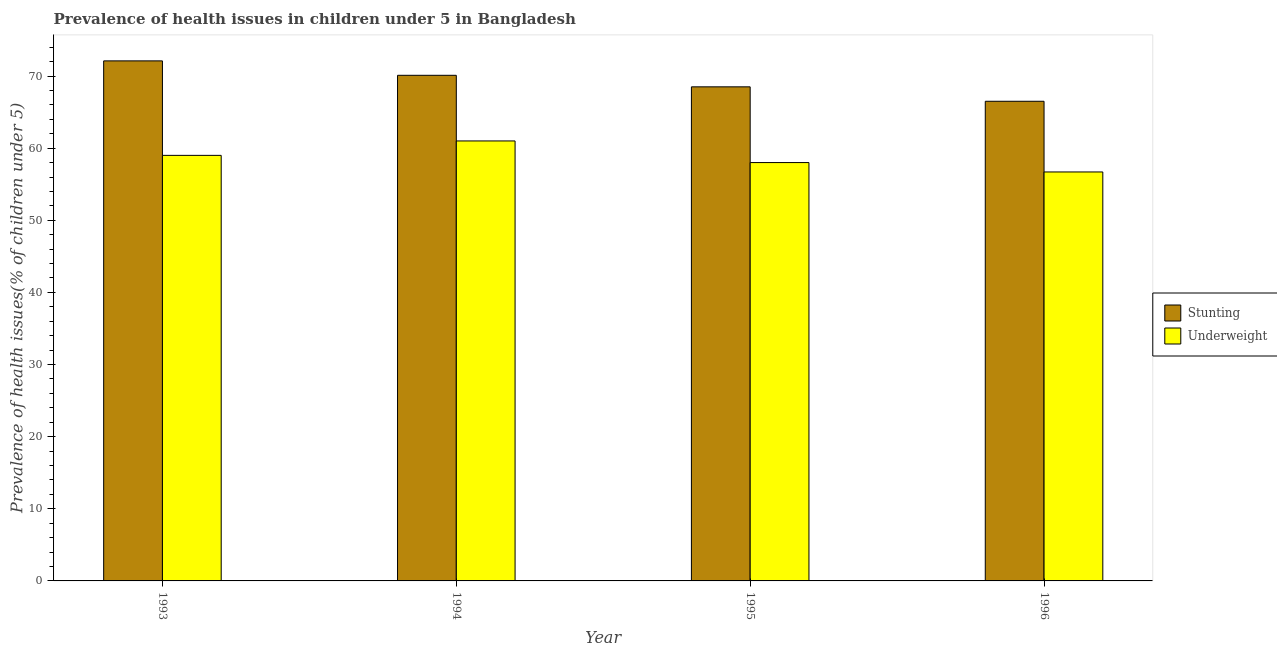How many different coloured bars are there?
Keep it short and to the point. 2. How many groups of bars are there?
Provide a short and direct response. 4. Are the number of bars per tick equal to the number of legend labels?
Give a very brief answer. Yes. Are the number of bars on each tick of the X-axis equal?
Offer a terse response. Yes. How many bars are there on the 2nd tick from the right?
Provide a short and direct response. 2. In how many cases, is the number of bars for a given year not equal to the number of legend labels?
Offer a terse response. 0. Across all years, what is the maximum percentage of underweight children?
Give a very brief answer. 61. Across all years, what is the minimum percentage of stunted children?
Keep it short and to the point. 66.5. In which year was the percentage of stunted children minimum?
Ensure brevity in your answer.  1996. What is the total percentage of underweight children in the graph?
Offer a terse response. 234.7. What is the difference between the percentage of stunted children in 1994 and that in 1996?
Offer a very short reply. 3.6. What is the average percentage of stunted children per year?
Your answer should be compact. 69.3. In how many years, is the percentage of stunted children greater than 10 %?
Your response must be concise. 4. What is the ratio of the percentage of stunted children in 1993 to that in 1995?
Keep it short and to the point. 1.05. Is the percentage of underweight children in 1993 less than that in 1994?
Your answer should be very brief. Yes. What is the difference between the highest and the second highest percentage of underweight children?
Offer a very short reply. 2. What is the difference between the highest and the lowest percentage of underweight children?
Make the answer very short. 4.3. In how many years, is the percentage of stunted children greater than the average percentage of stunted children taken over all years?
Your answer should be very brief. 2. What does the 2nd bar from the left in 1993 represents?
Provide a succinct answer. Underweight. What does the 1st bar from the right in 1995 represents?
Give a very brief answer. Underweight. How many years are there in the graph?
Make the answer very short. 4. Are the values on the major ticks of Y-axis written in scientific E-notation?
Give a very brief answer. No. Does the graph contain any zero values?
Offer a terse response. No. Where does the legend appear in the graph?
Your answer should be compact. Center right. How are the legend labels stacked?
Provide a short and direct response. Vertical. What is the title of the graph?
Give a very brief answer. Prevalence of health issues in children under 5 in Bangladesh. What is the label or title of the Y-axis?
Provide a succinct answer. Prevalence of health issues(% of children under 5). What is the Prevalence of health issues(% of children under 5) of Stunting in 1993?
Offer a terse response. 72.1. What is the Prevalence of health issues(% of children under 5) in Underweight in 1993?
Make the answer very short. 59. What is the Prevalence of health issues(% of children under 5) of Stunting in 1994?
Offer a very short reply. 70.1. What is the Prevalence of health issues(% of children under 5) in Underweight in 1994?
Provide a succinct answer. 61. What is the Prevalence of health issues(% of children under 5) in Stunting in 1995?
Your answer should be compact. 68.5. What is the Prevalence of health issues(% of children under 5) of Underweight in 1995?
Give a very brief answer. 58. What is the Prevalence of health issues(% of children under 5) in Stunting in 1996?
Provide a succinct answer. 66.5. What is the Prevalence of health issues(% of children under 5) of Underweight in 1996?
Keep it short and to the point. 56.7. Across all years, what is the maximum Prevalence of health issues(% of children under 5) of Stunting?
Make the answer very short. 72.1. Across all years, what is the maximum Prevalence of health issues(% of children under 5) of Underweight?
Offer a very short reply. 61. Across all years, what is the minimum Prevalence of health issues(% of children under 5) of Stunting?
Provide a short and direct response. 66.5. Across all years, what is the minimum Prevalence of health issues(% of children under 5) of Underweight?
Provide a succinct answer. 56.7. What is the total Prevalence of health issues(% of children under 5) in Stunting in the graph?
Provide a short and direct response. 277.2. What is the total Prevalence of health issues(% of children under 5) in Underweight in the graph?
Give a very brief answer. 234.7. What is the difference between the Prevalence of health issues(% of children under 5) in Stunting in 1993 and that in 1996?
Keep it short and to the point. 5.6. What is the difference between the Prevalence of health issues(% of children under 5) in Underweight in 1993 and that in 1996?
Your answer should be very brief. 2.3. What is the difference between the Prevalence of health issues(% of children under 5) of Stunting in 1995 and that in 1996?
Provide a short and direct response. 2. What is the difference between the Prevalence of health issues(% of children under 5) in Underweight in 1995 and that in 1996?
Your response must be concise. 1.3. What is the difference between the Prevalence of health issues(% of children under 5) of Stunting in 1993 and the Prevalence of health issues(% of children under 5) of Underweight in 1994?
Give a very brief answer. 11.1. What is the difference between the Prevalence of health issues(% of children under 5) of Stunting in 1993 and the Prevalence of health issues(% of children under 5) of Underweight in 1996?
Ensure brevity in your answer.  15.4. What is the difference between the Prevalence of health issues(% of children under 5) in Stunting in 1994 and the Prevalence of health issues(% of children under 5) in Underweight in 1995?
Make the answer very short. 12.1. What is the average Prevalence of health issues(% of children under 5) in Stunting per year?
Provide a succinct answer. 69.3. What is the average Prevalence of health issues(% of children under 5) of Underweight per year?
Offer a terse response. 58.67. In the year 1994, what is the difference between the Prevalence of health issues(% of children under 5) in Stunting and Prevalence of health issues(% of children under 5) in Underweight?
Offer a very short reply. 9.1. What is the ratio of the Prevalence of health issues(% of children under 5) of Stunting in 1993 to that in 1994?
Provide a succinct answer. 1.03. What is the ratio of the Prevalence of health issues(% of children under 5) of Underweight in 1993 to that in 1994?
Your response must be concise. 0.97. What is the ratio of the Prevalence of health issues(% of children under 5) of Stunting in 1993 to that in 1995?
Provide a succinct answer. 1.05. What is the ratio of the Prevalence of health issues(% of children under 5) of Underweight in 1993 to that in 1995?
Make the answer very short. 1.02. What is the ratio of the Prevalence of health issues(% of children under 5) in Stunting in 1993 to that in 1996?
Offer a very short reply. 1.08. What is the ratio of the Prevalence of health issues(% of children under 5) in Underweight in 1993 to that in 1996?
Make the answer very short. 1.04. What is the ratio of the Prevalence of health issues(% of children under 5) in Stunting in 1994 to that in 1995?
Your answer should be compact. 1.02. What is the ratio of the Prevalence of health issues(% of children under 5) in Underweight in 1994 to that in 1995?
Your answer should be very brief. 1.05. What is the ratio of the Prevalence of health issues(% of children under 5) of Stunting in 1994 to that in 1996?
Give a very brief answer. 1.05. What is the ratio of the Prevalence of health issues(% of children under 5) of Underweight in 1994 to that in 1996?
Make the answer very short. 1.08. What is the ratio of the Prevalence of health issues(% of children under 5) of Stunting in 1995 to that in 1996?
Your answer should be very brief. 1.03. What is the ratio of the Prevalence of health issues(% of children under 5) in Underweight in 1995 to that in 1996?
Provide a short and direct response. 1.02. What is the difference between the highest and the second highest Prevalence of health issues(% of children under 5) in Stunting?
Provide a short and direct response. 2. What is the difference between the highest and the lowest Prevalence of health issues(% of children under 5) of Stunting?
Provide a succinct answer. 5.6. 